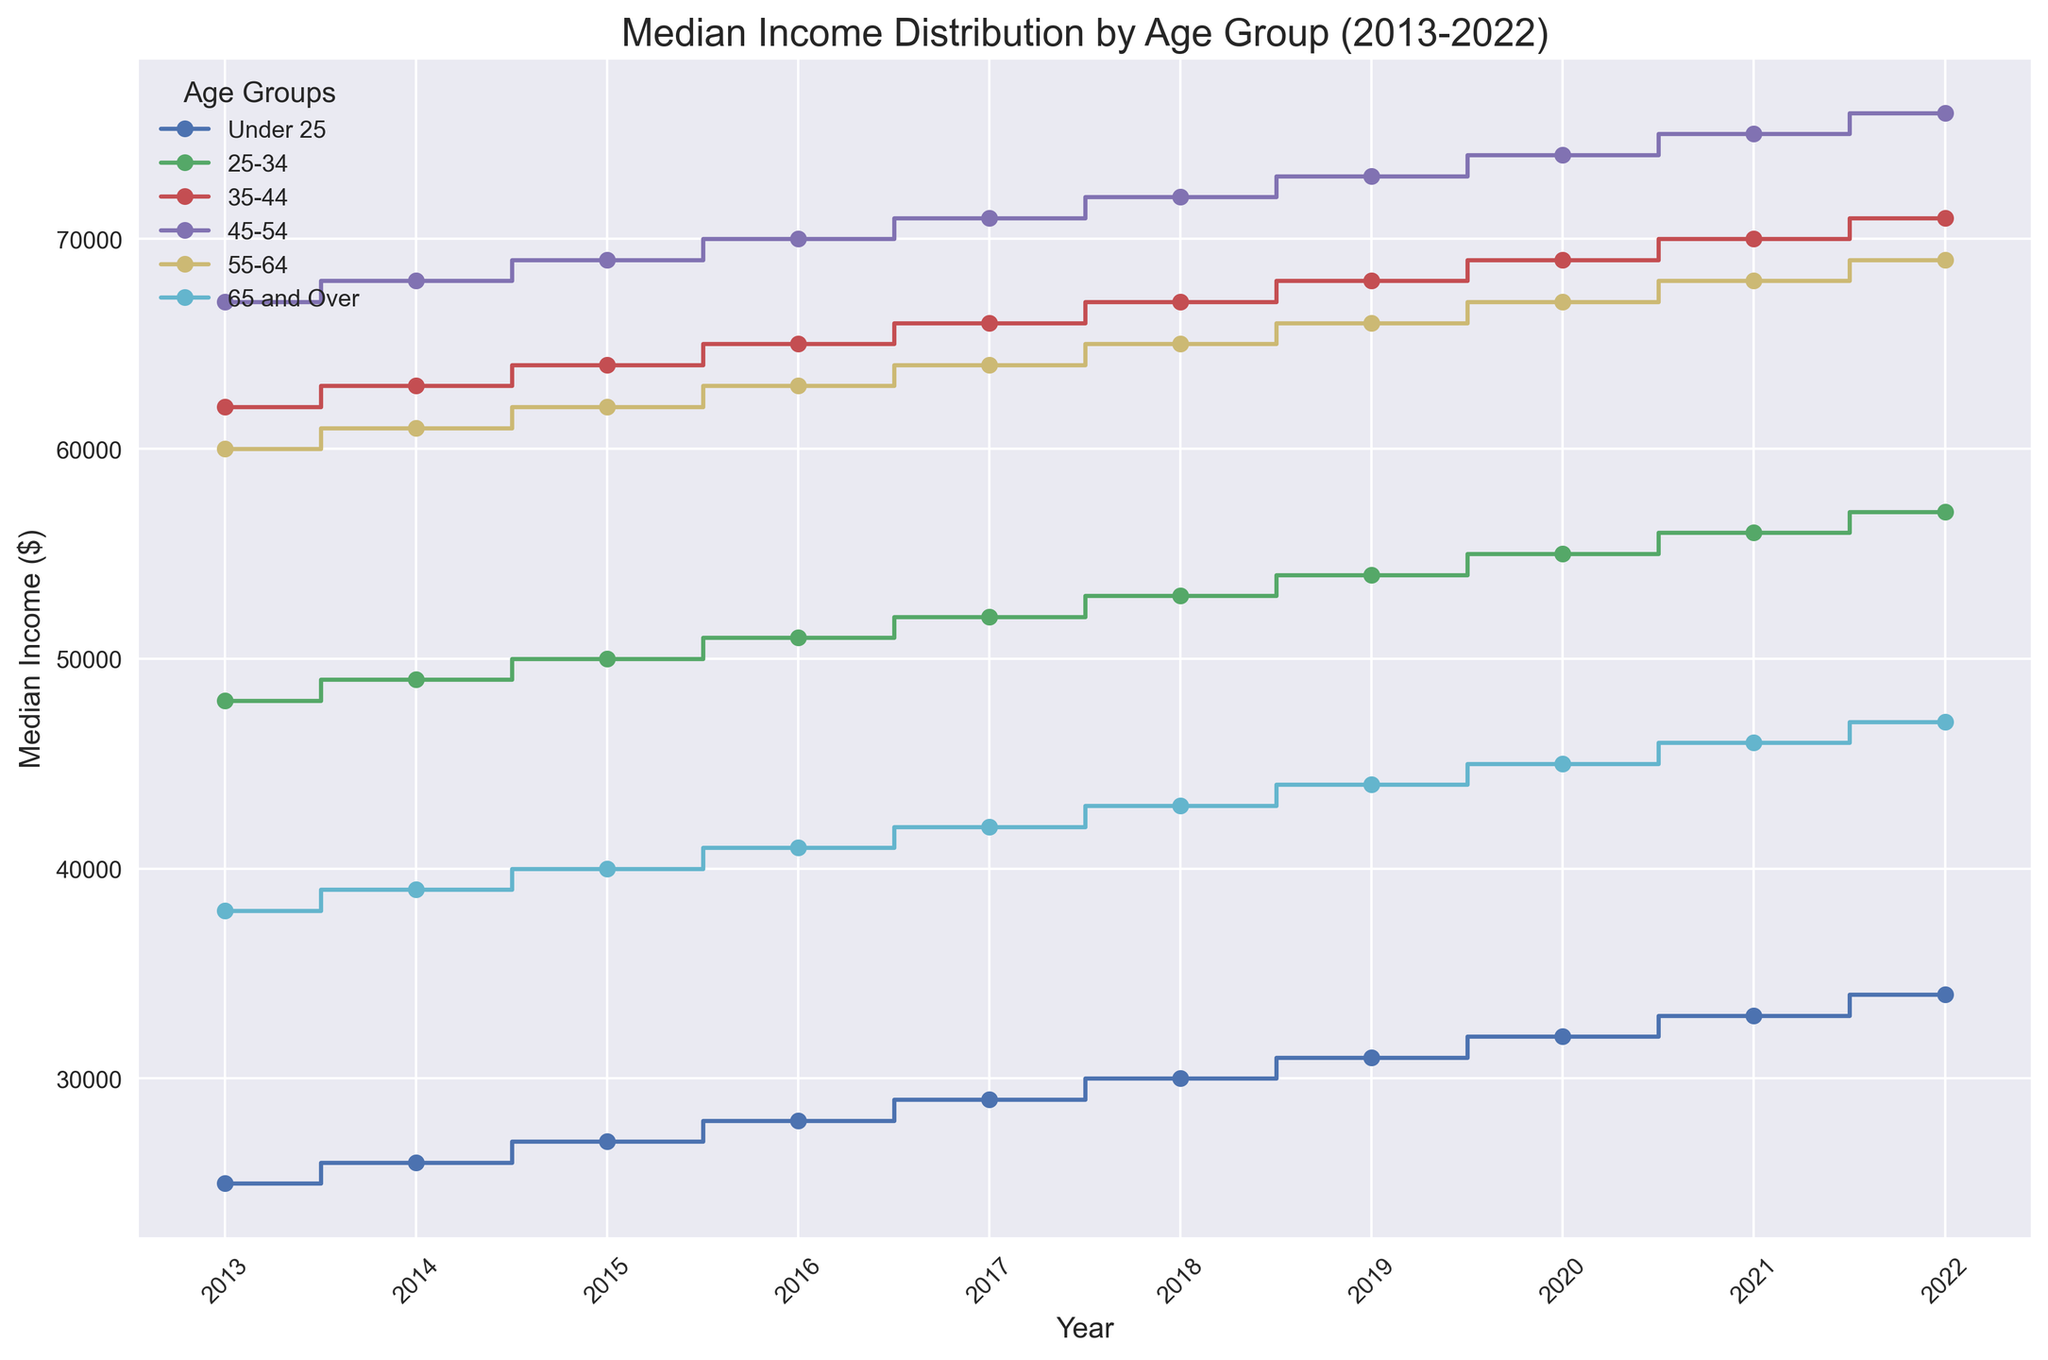What is the median income for the age group "35-44" in 2022? The 2022 data for the "35-44" age group shows a median income at the 2022 mark on the x-axis and the corresponding value on the y-axis.
Answer: 71000 Which age group has the highest median income in 2021? By inspecting the 2021 mark on the x-axis and comparing the heights of the steps for each age group, the "45-54" group has the highest value on the y-axis.
Answer: 45-54 What is the median income difference between the "25-34" and "65 and Over" age groups in 2020? Locate the 2020 median income values for both "25-34" and "65 and Over" groups. Subtract the "65 and Over" value from the "25-34" value: 55000 - 45000.
Answer: 10000 Which age group has the smallest increase in median income from 2013 to 2022? Calculate the difference in median income for each age group by subtracting the 2013 value from the 2022 value. The "45-54" increases by (76000-67000), "35-44" by (71000-62000), and so on. The "Under 25" group has the smallest increase: 34000 - 25000.
Answer: Under 25 Between which consecutive years does the "55-64" age group show the highest increase in median income? Calculate the year-to-year difference for the "55-64" age group for all consecutive years. The differences are 61000-60000, 62000-61000, etc. The highest yearly increase is (2022: 69000 - 2021: 68000).
Answer: 2021 to 2022 What is the average median income for the "45-54" age group over the decade? Sum the median incomes for the "45-54" age group from 2013 to 2022 and divide by the number of years: (67000 + 68000 + 69000 + 70000 + 71000 +72000 + 73000 + 74000 + 75000 + 76000)/10. The calculation yields: 72500.
Answer: 72500 Which age group has the lowest median income in 2016? Inspect the median income values for each age group in 2016. The "Under 25" group has the lowest value on the y-axis.
Answer: Under 25 How much did the median income for the "65 and Over" age group increase from 2013 to 2022? Subtract the 2013 median income of the "65 and Over" group from the 2022 value: 47000 - 38000.
Answer: 9000 